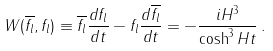Convert formula to latex. <formula><loc_0><loc_0><loc_500><loc_500>W ( \overline { f _ { l } } , f _ { l } ) \equiv \overline { f _ { l } } \frac { d f _ { l } } { d t } - f _ { l } \frac { d \overline { f _ { l } } } { d t } = - \frac { i H ^ { 3 } } { \cosh ^ { 3 } H t } \, .</formula> 